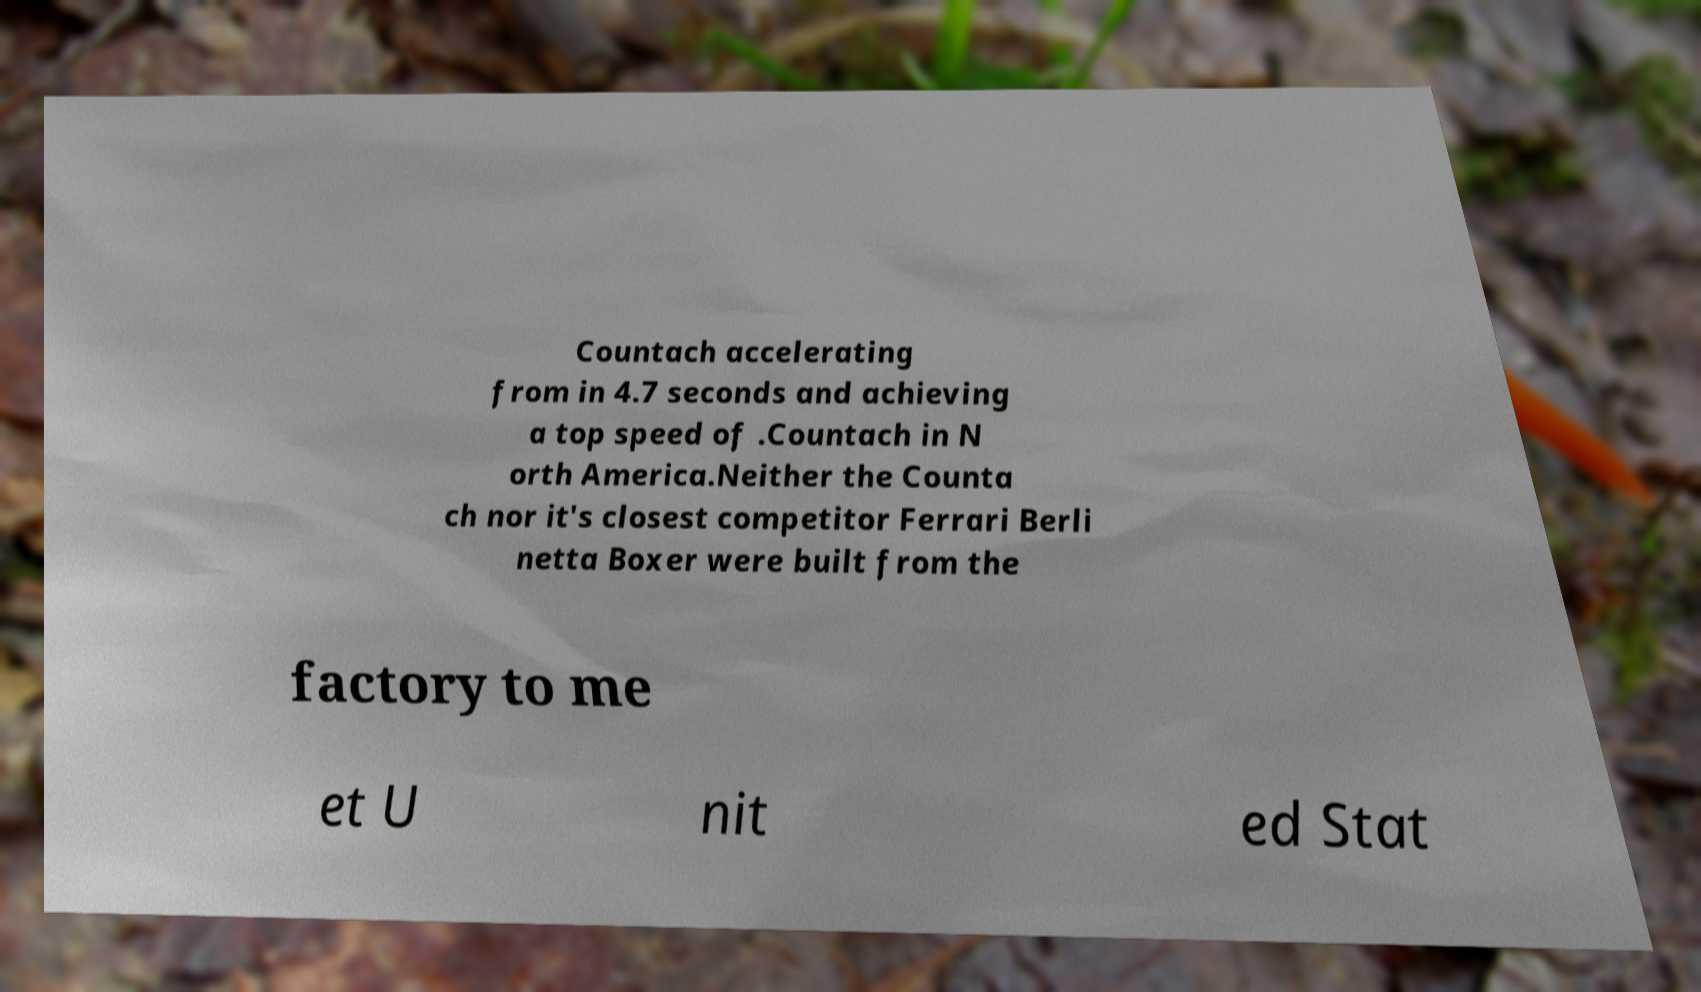Please read and relay the text visible in this image. What does it say? Countach accelerating from in 4.7 seconds and achieving a top speed of .Countach in N orth America.Neither the Counta ch nor it's closest competitor Ferrari Berli netta Boxer were built from the factory to me et U nit ed Stat 